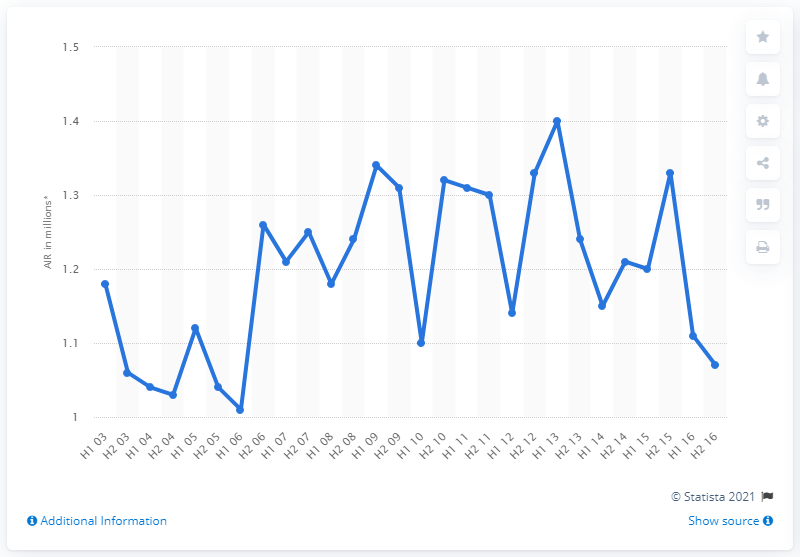Highlight a few significant elements in this photo. In the second half of 2015, the average number of readers per issue of Vogue was 1.3. 